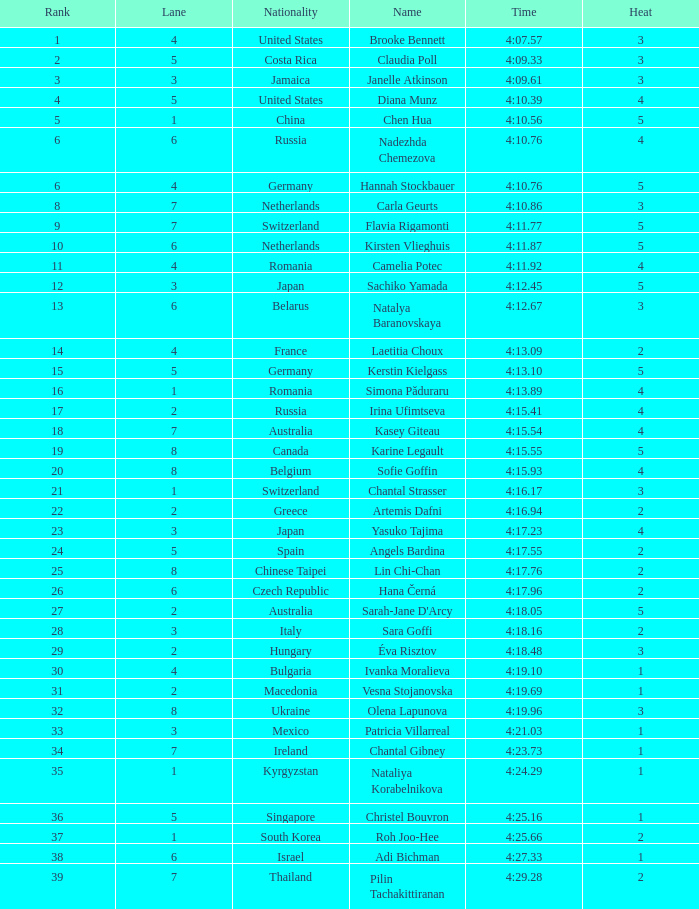Name the least lane for kasey giteau and rank less than 18 None. 